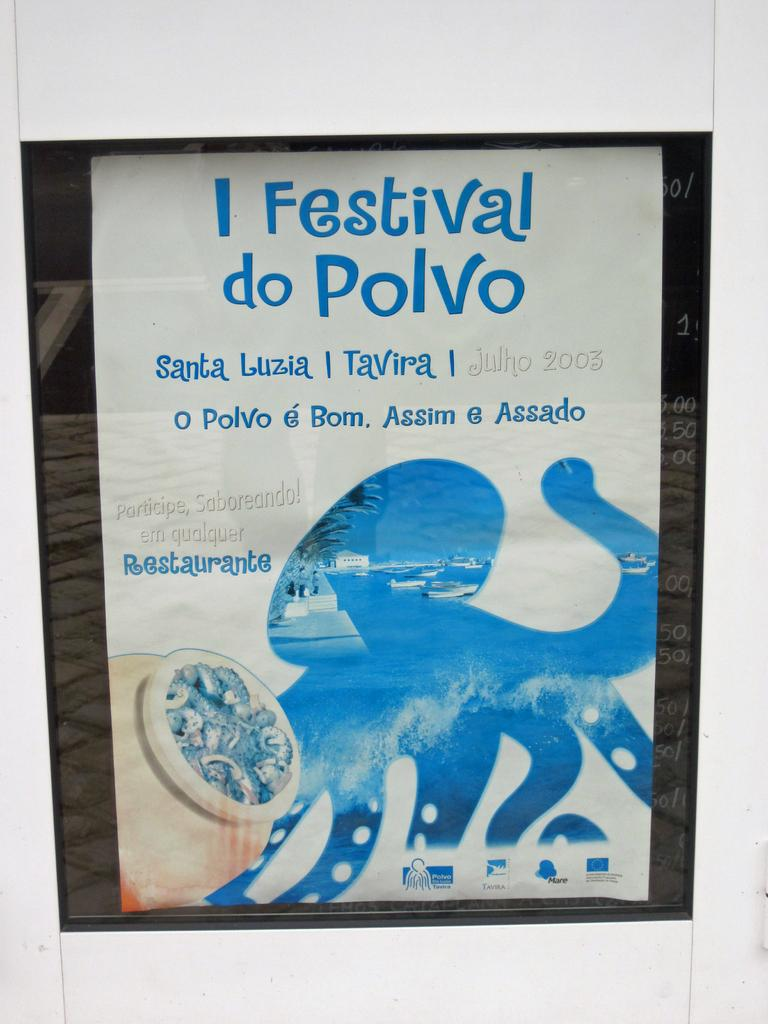<image>
Offer a succinct explanation of the picture presented. A poster featuring a cartoon octopus represents the Festival do Polvo. 